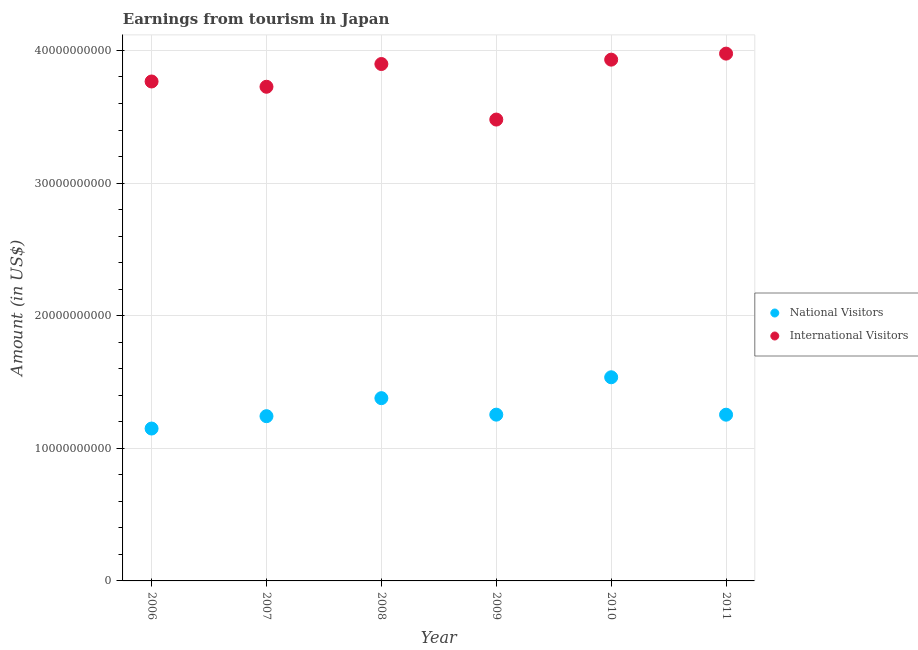What is the amount earned from international visitors in 2007?
Ensure brevity in your answer.  3.73e+1. Across all years, what is the maximum amount earned from national visitors?
Provide a short and direct response. 1.54e+1. Across all years, what is the minimum amount earned from national visitors?
Your response must be concise. 1.15e+1. In which year was the amount earned from international visitors minimum?
Provide a short and direct response. 2009. What is the total amount earned from national visitors in the graph?
Your answer should be compact. 7.81e+1. What is the difference between the amount earned from international visitors in 2007 and that in 2011?
Give a very brief answer. -2.50e+09. What is the difference between the amount earned from international visitors in 2010 and the amount earned from national visitors in 2006?
Provide a succinct answer. 2.78e+1. What is the average amount earned from national visitors per year?
Provide a succinct answer. 1.30e+1. In the year 2009, what is the difference between the amount earned from international visitors and amount earned from national visitors?
Keep it short and to the point. 2.23e+1. In how many years, is the amount earned from international visitors greater than 32000000000 US$?
Ensure brevity in your answer.  6. What is the ratio of the amount earned from international visitors in 2008 to that in 2009?
Ensure brevity in your answer.  1.12. Is the amount earned from national visitors in 2008 less than that in 2011?
Keep it short and to the point. No. Is the difference between the amount earned from national visitors in 2007 and 2008 greater than the difference between the amount earned from international visitors in 2007 and 2008?
Your answer should be compact. Yes. What is the difference between the highest and the second highest amount earned from national visitors?
Your answer should be compact. 1.58e+09. What is the difference between the highest and the lowest amount earned from national visitors?
Keep it short and to the point. 3.87e+09. In how many years, is the amount earned from international visitors greater than the average amount earned from international visitors taken over all years?
Provide a short and direct response. 3. Is the sum of the amount earned from national visitors in 2006 and 2007 greater than the maximum amount earned from international visitors across all years?
Ensure brevity in your answer.  No. How many dotlines are there?
Your answer should be compact. 2. What is the difference between two consecutive major ticks on the Y-axis?
Offer a terse response. 1.00e+1. Does the graph contain any zero values?
Offer a terse response. No. Does the graph contain grids?
Give a very brief answer. Yes. Where does the legend appear in the graph?
Ensure brevity in your answer.  Center right. How are the legend labels stacked?
Offer a very short reply. Vertical. What is the title of the graph?
Ensure brevity in your answer.  Earnings from tourism in Japan. What is the Amount (in US$) in National Visitors in 2006?
Keep it short and to the point. 1.15e+1. What is the Amount (in US$) of International Visitors in 2006?
Your answer should be compact. 3.77e+1. What is the Amount (in US$) of National Visitors in 2007?
Keep it short and to the point. 1.24e+1. What is the Amount (in US$) in International Visitors in 2007?
Offer a terse response. 3.73e+1. What is the Amount (in US$) of National Visitors in 2008?
Provide a succinct answer. 1.38e+1. What is the Amount (in US$) in International Visitors in 2008?
Make the answer very short. 3.90e+1. What is the Amount (in US$) in National Visitors in 2009?
Offer a terse response. 1.25e+1. What is the Amount (in US$) of International Visitors in 2009?
Give a very brief answer. 3.48e+1. What is the Amount (in US$) in National Visitors in 2010?
Ensure brevity in your answer.  1.54e+1. What is the Amount (in US$) in International Visitors in 2010?
Offer a terse response. 3.93e+1. What is the Amount (in US$) of National Visitors in 2011?
Your response must be concise. 1.25e+1. What is the Amount (in US$) in International Visitors in 2011?
Give a very brief answer. 3.98e+1. Across all years, what is the maximum Amount (in US$) of National Visitors?
Provide a succinct answer. 1.54e+1. Across all years, what is the maximum Amount (in US$) in International Visitors?
Keep it short and to the point. 3.98e+1. Across all years, what is the minimum Amount (in US$) in National Visitors?
Offer a terse response. 1.15e+1. Across all years, what is the minimum Amount (in US$) in International Visitors?
Keep it short and to the point. 3.48e+1. What is the total Amount (in US$) of National Visitors in the graph?
Keep it short and to the point. 7.81e+1. What is the total Amount (in US$) in International Visitors in the graph?
Keep it short and to the point. 2.28e+11. What is the difference between the Amount (in US$) of National Visitors in 2006 and that in 2007?
Keep it short and to the point. -9.32e+08. What is the difference between the Amount (in US$) in International Visitors in 2006 and that in 2007?
Keep it short and to the point. 3.98e+08. What is the difference between the Amount (in US$) in National Visitors in 2006 and that in 2008?
Make the answer very short. -2.29e+09. What is the difference between the Amount (in US$) of International Visitors in 2006 and that in 2008?
Keep it short and to the point. -1.32e+09. What is the difference between the Amount (in US$) of National Visitors in 2006 and that in 2009?
Keep it short and to the point. -1.05e+09. What is the difference between the Amount (in US$) in International Visitors in 2006 and that in 2009?
Your response must be concise. 2.87e+09. What is the difference between the Amount (in US$) in National Visitors in 2006 and that in 2010?
Keep it short and to the point. -3.87e+09. What is the difference between the Amount (in US$) of International Visitors in 2006 and that in 2010?
Ensure brevity in your answer.  -1.65e+09. What is the difference between the Amount (in US$) of National Visitors in 2006 and that in 2011?
Offer a terse response. -1.04e+09. What is the difference between the Amount (in US$) of International Visitors in 2006 and that in 2011?
Give a very brief answer. -2.10e+09. What is the difference between the Amount (in US$) in National Visitors in 2007 and that in 2008?
Provide a short and direct response. -1.36e+09. What is the difference between the Amount (in US$) of International Visitors in 2007 and that in 2008?
Offer a very short reply. -1.72e+09. What is the difference between the Amount (in US$) of National Visitors in 2007 and that in 2009?
Provide a succinct answer. -1.15e+08. What is the difference between the Amount (in US$) in International Visitors in 2007 and that in 2009?
Give a very brief answer. 2.47e+09. What is the difference between the Amount (in US$) of National Visitors in 2007 and that in 2010?
Your answer should be compact. -2.93e+09. What is the difference between the Amount (in US$) of International Visitors in 2007 and that in 2010?
Keep it short and to the point. -2.04e+09. What is the difference between the Amount (in US$) in National Visitors in 2007 and that in 2011?
Ensure brevity in your answer.  -1.12e+08. What is the difference between the Amount (in US$) of International Visitors in 2007 and that in 2011?
Provide a succinct answer. -2.50e+09. What is the difference between the Amount (in US$) in National Visitors in 2008 and that in 2009?
Your answer should be compact. 1.24e+09. What is the difference between the Amount (in US$) of International Visitors in 2008 and that in 2009?
Give a very brief answer. 4.19e+09. What is the difference between the Amount (in US$) in National Visitors in 2008 and that in 2010?
Offer a terse response. -1.58e+09. What is the difference between the Amount (in US$) in International Visitors in 2008 and that in 2010?
Provide a short and direct response. -3.30e+08. What is the difference between the Amount (in US$) in National Visitors in 2008 and that in 2011?
Your response must be concise. 1.25e+09. What is the difference between the Amount (in US$) in International Visitors in 2008 and that in 2011?
Provide a short and direct response. -7.84e+08. What is the difference between the Amount (in US$) in National Visitors in 2009 and that in 2010?
Make the answer very short. -2.82e+09. What is the difference between the Amount (in US$) of International Visitors in 2009 and that in 2010?
Your answer should be compact. -4.52e+09. What is the difference between the Amount (in US$) of National Visitors in 2009 and that in 2011?
Provide a succinct answer. 3.00e+06. What is the difference between the Amount (in US$) of International Visitors in 2009 and that in 2011?
Your response must be concise. -4.97e+09. What is the difference between the Amount (in US$) in National Visitors in 2010 and that in 2011?
Your response must be concise. 2.82e+09. What is the difference between the Amount (in US$) of International Visitors in 2010 and that in 2011?
Your response must be concise. -4.54e+08. What is the difference between the Amount (in US$) in National Visitors in 2006 and the Amount (in US$) in International Visitors in 2007?
Make the answer very short. -2.58e+1. What is the difference between the Amount (in US$) of National Visitors in 2006 and the Amount (in US$) of International Visitors in 2008?
Offer a terse response. -2.75e+1. What is the difference between the Amount (in US$) in National Visitors in 2006 and the Amount (in US$) in International Visitors in 2009?
Make the answer very short. -2.33e+1. What is the difference between the Amount (in US$) of National Visitors in 2006 and the Amount (in US$) of International Visitors in 2010?
Offer a terse response. -2.78e+1. What is the difference between the Amount (in US$) in National Visitors in 2006 and the Amount (in US$) in International Visitors in 2011?
Offer a very short reply. -2.83e+1. What is the difference between the Amount (in US$) of National Visitors in 2007 and the Amount (in US$) of International Visitors in 2008?
Keep it short and to the point. -2.66e+1. What is the difference between the Amount (in US$) in National Visitors in 2007 and the Amount (in US$) in International Visitors in 2009?
Your answer should be compact. -2.24e+1. What is the difference between the Amount (in US$) of National Visitors in 2007 and the Amount (in US$) of International Visitors in 2010?
Provide a succinct answer. -2.69e+1. What is the difference between the Amount (in US$) of National Visitors in 2007 and the Amount (in US$) of International Visitors in 2011?
Give a very brief answer. -2.73e+1. What is the difference between the Amount (in US$) of National Visitors in 2008 and the Amount (in US$) of International Visitors in 2009?
Your answer should be very brief. -2.10e+1. What is the difference between the Amount (in US$) of National Visitors in 2008 and the Amount (in US$) of International Visitors in 2010?
Offer a terse response. -2.55e+1. What is the difference between the Amount (in US$) in National Visitors in 2008 and the Amount (in US$) in International Visitors in 2011?
Offer a terse response. -2.60e+1. What is the difference between the Amount (in US$) of National Visitors in 2009 and the Amount (in US$) of International Visitors in 2010?
Provide a succinct answer. -2.68e+1. What is the difference between the Amount (in US$) of National Visitors in 2009 and the Amount (in US$) of International Visitors in 2011?
Make the answer very short. -2.72e+1. What is the difference between the Amount (in US$) of National Visitors in 2010 and the Amount (in US$) of International Visitors in 2011?
Offer a very short reply. -2.44e+1. What is the average Amount (in US$) of National Visitors per year?
Provide a short and direct response. 1.30e+1. What is the average Amount (in US$) in International Visitors per year?
Give a very brief answer. 3.80e+1. In the year 2006, what is the difference between the Amount (in US$) in National Visitors and Amount (in US$) in International Visitors?
Keep it short and to the point. -2.62e+1. In the year 2007, what is the difference between the Amount (in US$) of National Visitors and Amount (in US$) of International Visitors?
Give a very brief answer. -2.48e+1. In the year 2008, what is the difference between the Amount (in US$) in National Visitors and Amount (in US$) in International Visitors?
Provide a succinct answer. -2.52e+1. In the year 2009, what is the difference between the Amount (in US$) in National Visitors and Amount (in US$) in International Visitors?
Your answer should be compact. -2.23e+1. In the year 2010, what is the difference between the Amount (in US$) of National Visitors and Amount (in US$) of International Visitors?
Offer a very short reply. -2.40e+1. In the year 2011, what is the difference between the Amount (in US$) of National Visitors and Amount (in US$) of International Visitors?
Provide a short and direct response. -2.72e+1. What is the ratio of the Amount (in US$) of National Visitors in 2006 to that in 2007?
Your answer should be compact. 0.93. What is the ratio of the Amount (in US$) of International Visitors in 2006 to that in 2007?
Offer a very short reply. 1.01. What is the ratio of the Amount (in US$) in National Visitors in 2006 to that in 2008?
Your response must be concise. 0.83. What is the ratio of the Amount (in US$) of International Visitors in 2006 to that in 2008?
Keep it short and to the point. 0.97. What is the ratio of the Amount (in US$) of National Visitors in 2006 to that in 2009?
Ensure brevity in your answer.  0.92. What is the ratio of the Amount (in US$) in International Visitors in 2006 to that in 2009?
Ensure brevity in your answer.  1.08. What is the ratio of the Amount (in US$) in National Visitors in 2006 to that in 2010?
Your response must be concise. 0.75. What is the ratio of the Amount (in US$) in International Visitors in 2006 to that in 2010?
Your answer should be very brief. 0.96. What is the ratio of the Amount (in US$) in National Visitors in 2006 to that in 2011?
Provide a short and direct response. 0.92. What is the ratio of the Amount (in US$) in International Visitors in 2006 to that in 2011?
Provide a short and direct response. 0.95. What is the ratio of the Amount (in US$) of National Visitors in 2007 to that in 2008?
Your answer should be very brief. 0.9. What is the ratio of the Amount (in US$) in International Visitors in 2007 to that in 2008?
Keep it short and to the point. 0.96. What is the ratio of the Amount (in US$) in International Visitors in 2007 to that in 2009?
Ensure brevity in your answer.  1.07. What is the ratio of the Amount (in US$) in National Visitors in 2007 to that in 2010?
Offer a terse response. 0.81. What is the ratio of the Amount (in US$) of International Visitors in 2007 to that in 2010?
Give a very brief answer. 0.95. What is the ratio of the Amount (in US$) of National Visitors in 2007 to that in 2011?
Your answer should be compact. 0.99. What is the ratio of the Amount (in US$) of International Visitors in 2007 to that in 2011?
Make the answer very short. 0.94. What is the ratio of the Amount (in US$) in National Visitors in 2008 to that in 2009?
Provide a succinct answer. 1.1. What is the ratio of the Amount (in US$) of International Visitors in 2008 to that in 2009?
Ensure brevity in your answer.  1.12. What is the ratio of the Amount (in US$) in National Visitors in 2008 to that in 2010?
Provide a succinct answer. 0.9. What is the ratio of the Amount (in US$) in International Visitors in 2008 to that in 2010?
Provide a succinct answer. 0.99. What is the ratio of the Amount (in US$) of National Visitors in 2008 to that in 2011?
Offer a very short reply. 1.1. What is the ratio of the Amount (in US$) in International Visitors in 2008 to that in 2011?
Your answer should be compact. 0.98. What is the ratio of the Amount (in US$) in National Visitors in 2009 to that in 2010?
Give a very brief answer. 0.82. What is the ratio of the Amount (in US$) in International Visitors in 2009 to that in 2010?
Your answer should be very brief. 0.89. What is the ratio of the Amount (in US$) in International Visitors in 2009 to that in 2011?
Keep it short and to the point. 0.87. What is the ratio of the Amount (in US$) of National Visitors in 2010 to that in 2011?
Make the answer very short. 1.23. What is the difference between the highest and the second highest Amount (in US$) in National Visitors?
Your answer should be compact. 1.58e+09. What is the difference between the highest and the second highest Amount (in US$) in International Visitors?
Offer a very short reply. 4.54e+08. What is the difference between the highest and the lowest Amount (in US$) of National Visitors?
Give a very brief answer. 3.87e+09. What is the difference between the highest and the lowest Amount (in US$) in International Visitors?
Your response must be concise. 4.97e+09. 